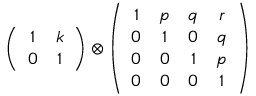<formula> <loc_0><loc_0><loc_500><loc_500>\left ( \begin{array} { c c } { 1 } & { k } \\ { 0 } & { 1 } \end{array} \right ) \otimes \left ( \begin{array} { c c c c } { 1 } & { p } & { q } & { r } \\ { 0 } & { 1 } & { 0 } & { q } \\ { 0 } & { 0 } & { 1 } & { p } \\ { 0 } & { 0 } & { 0 } & { 1 } \end{array} \right )</formula> 